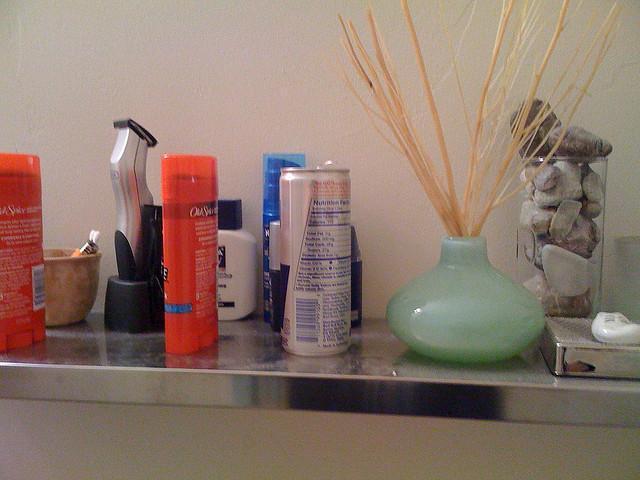How many deodorants are on the shelf?
Give a very brief answer. 2. How many cups are there?
Give a very brief answer. 2. 